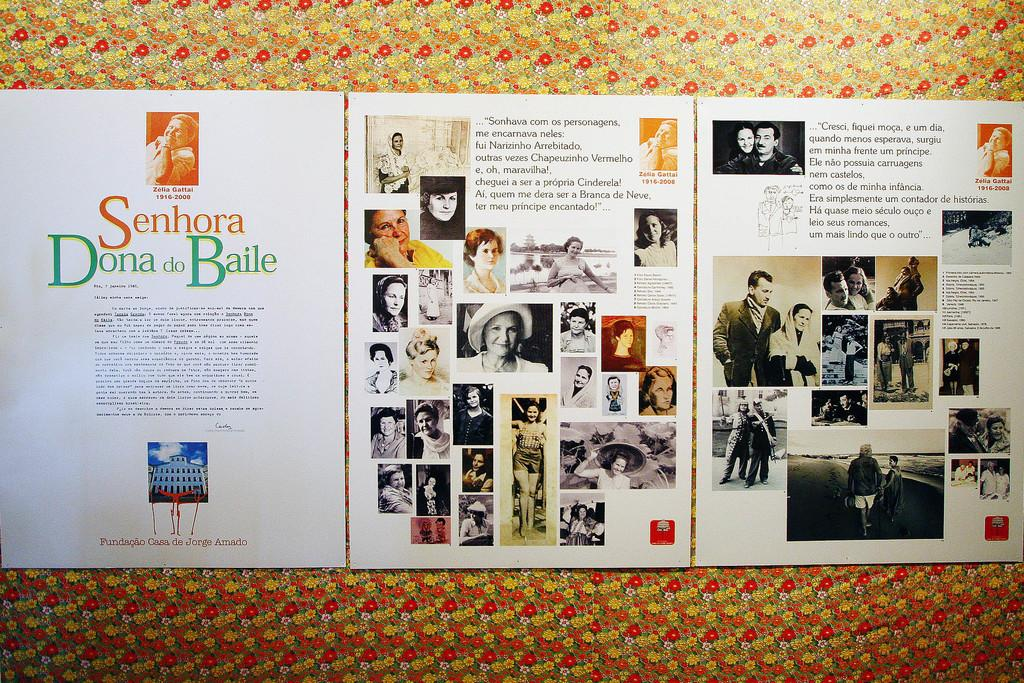<image>
Describe the image concisely. A several page spread displays images and information on Senhora Dona do Baile. 